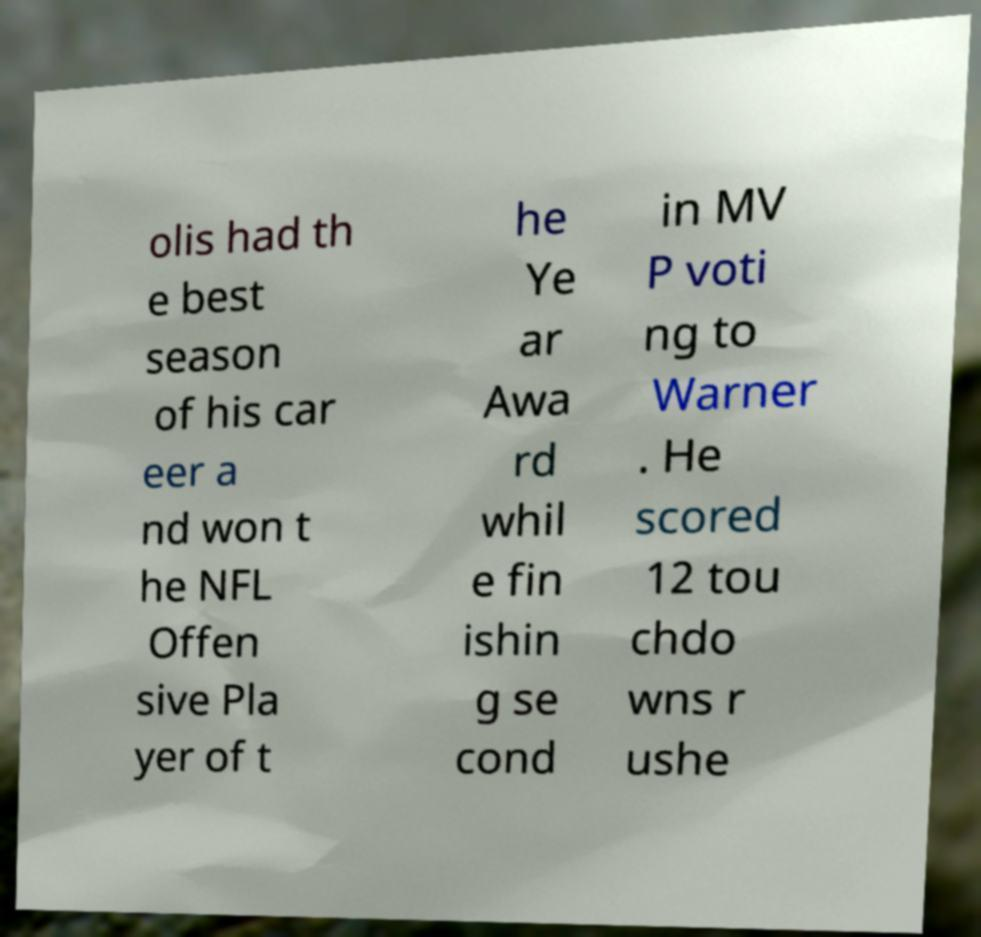Please read and relay the text visible in this image. What does it say? olis had th e best season of his car eer a nd won t he NFL Offen sive Pla yer of t he Ye ar Awa rd whil e fin ishin g se cond in MV P voti ng to Warner . He scored 12 tou chdo wns r ushe 